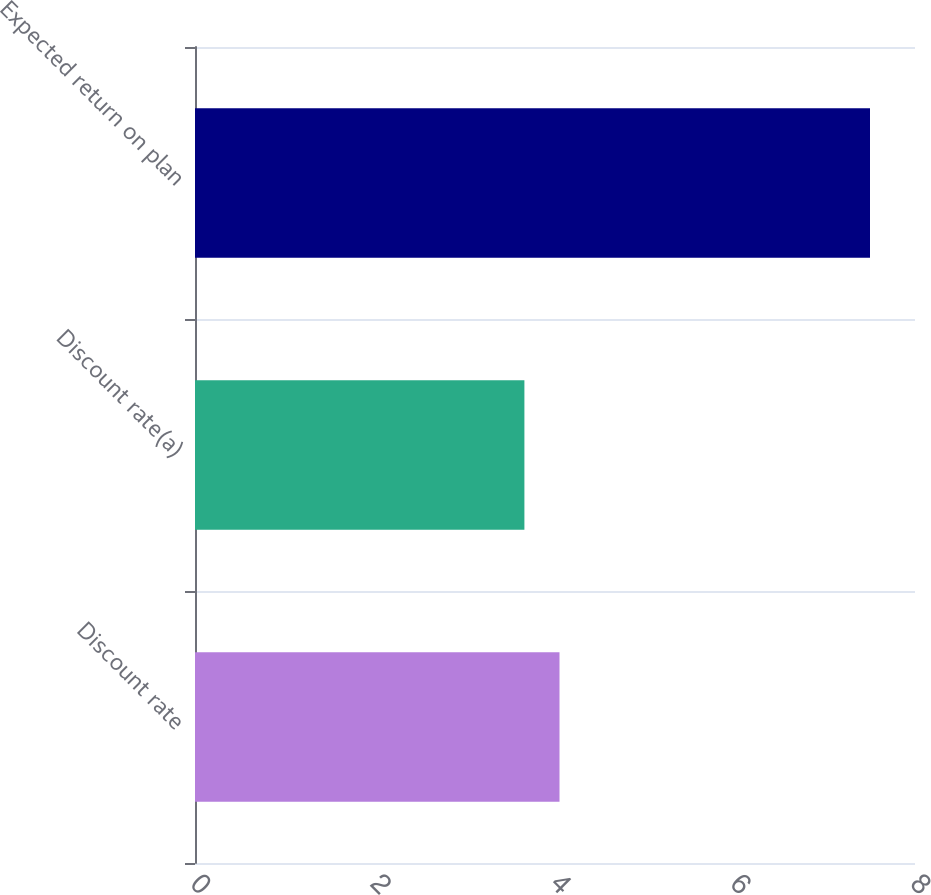Convert chart to OTSL. <chart><loc_0><loc_0><loc_500><loc_500><bar_chart><fcel>Discount rate<fcel>Discount rate(a)<fcel>Expected return on plan<nl><fcel>4.05<fcel>3.66<fcel>7.5<nl></chart> 